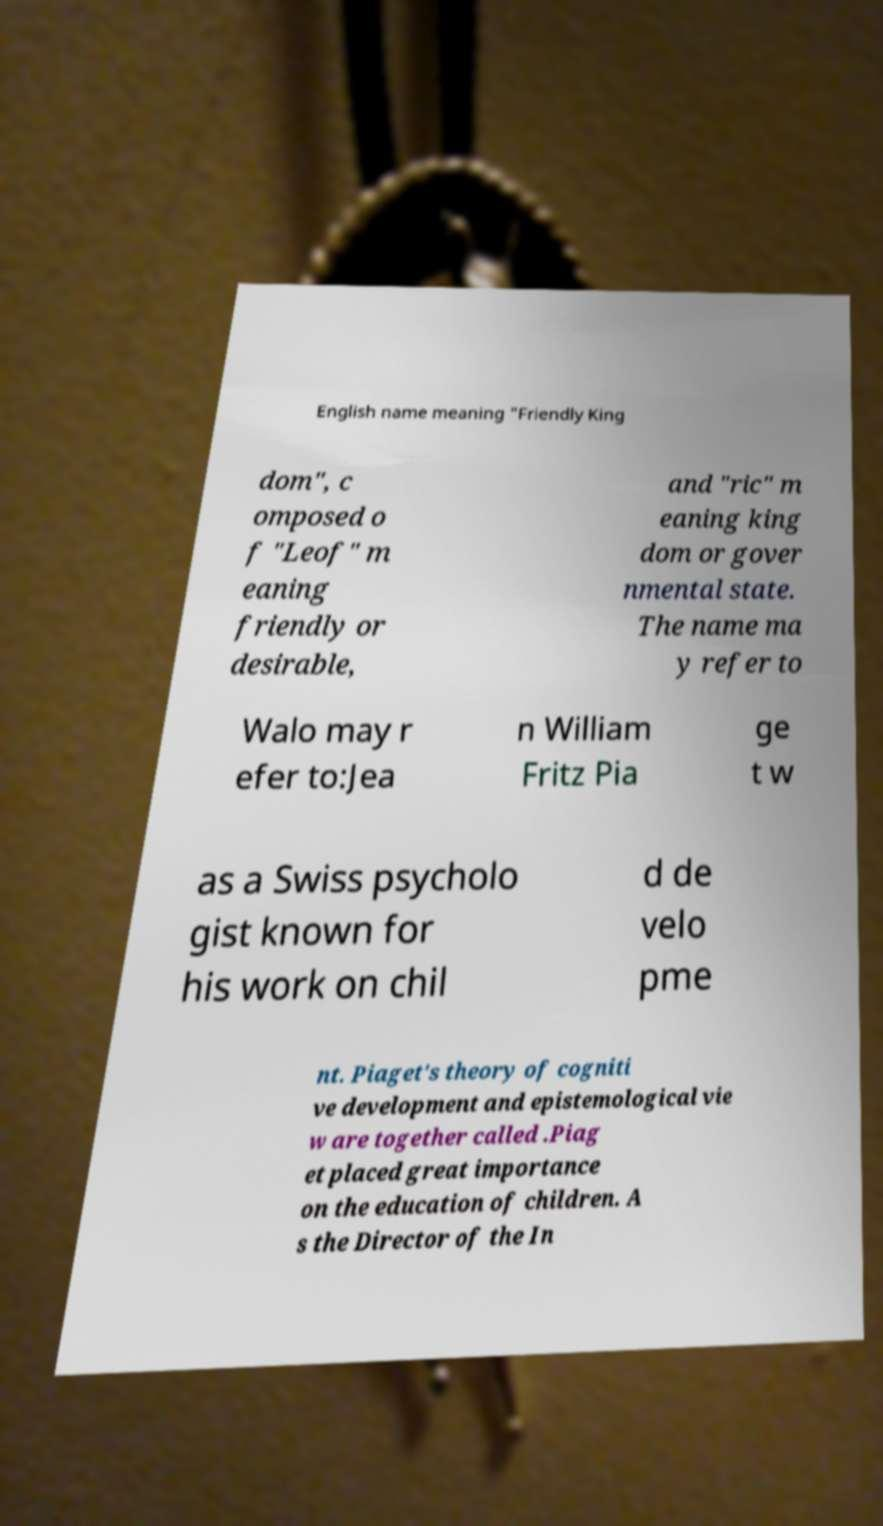Please identify and transcribe the text found in this image. English name meaning "Friendly King dom", c omposed o f "Leof" m eaning friendly or desirable, and "ric" m eaning king dom or gover nmental state. The name ma y refer to Walo may r efer to:Jea n William Fritz Pia ge t w as a Swiss psycholo gist known for his work on chil d de velo pme nt. Piaget's theory of cogniti ve development and epistemological vie w are together called .Piag et placed great importance on the education of children. A s the Director of the In 